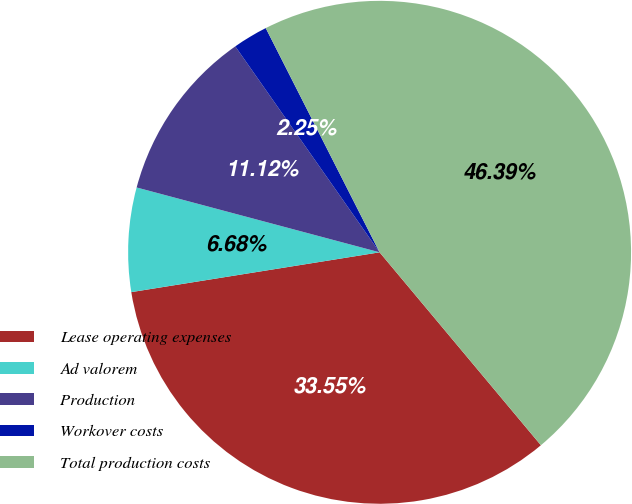Convert chart to OTSL. <chart><loc_0><loc_0><loc_500><loc_500><pie_chart><fcel>Lease operating expenses<fcel>Ad valorem<fcel>Production<fcel>Workover costs<fcel>Total production costs<nl><fcel>33.55%<fcel>6.68%<fcel>11.12%<fcel>2.25%<fcel>46.39%<nl></chart> 